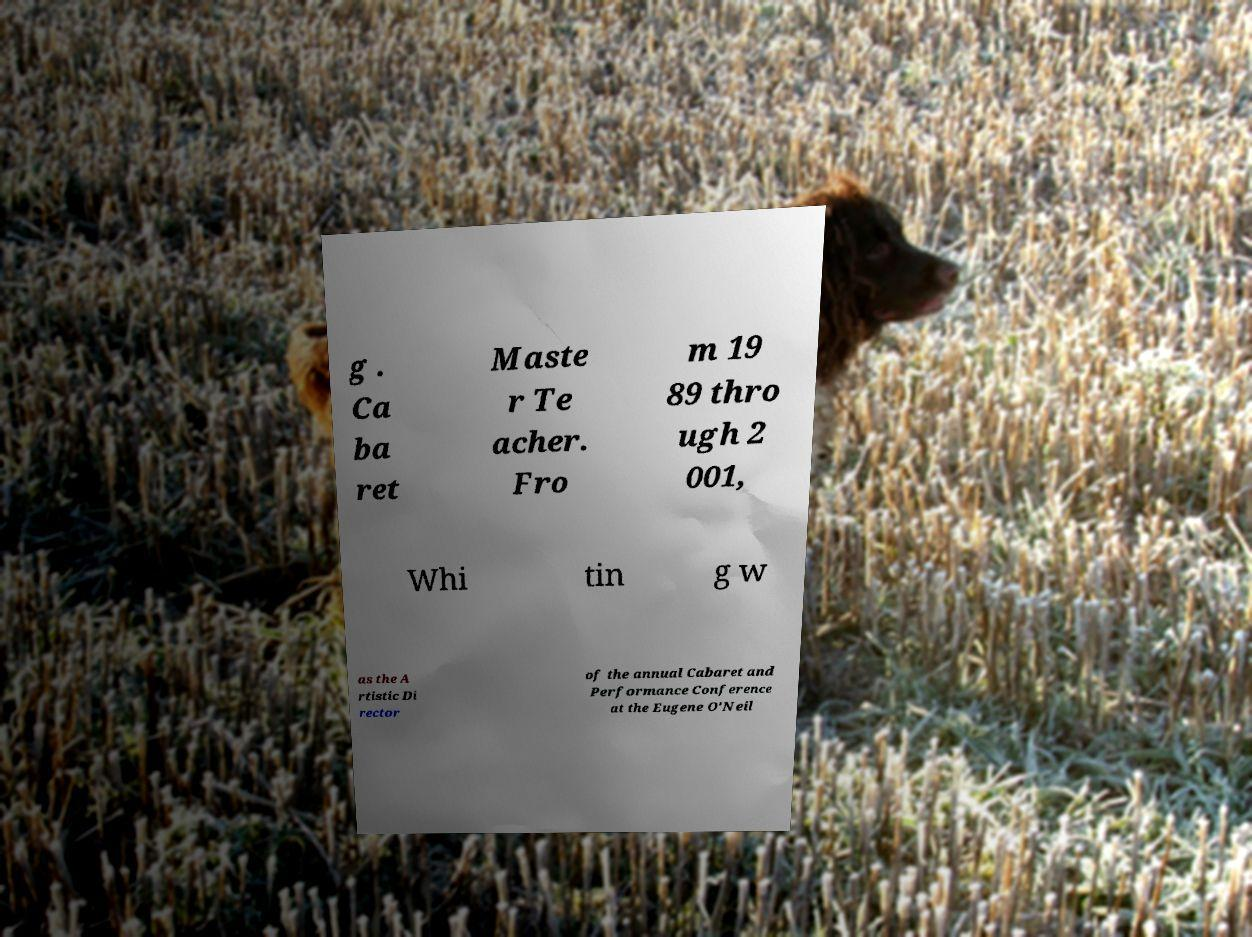Can you read and provide the text displayed in the image?This photo seems to have some interesting text. Can you extract and type it out for me? g . Ca ba ret Maste r Te acher. Fro m 19 89 thro ugh 2 001, Whi tin g w as the A rtistic Di rector of the annual Cabaret and Performance Conference at the Eugene O'Neil 